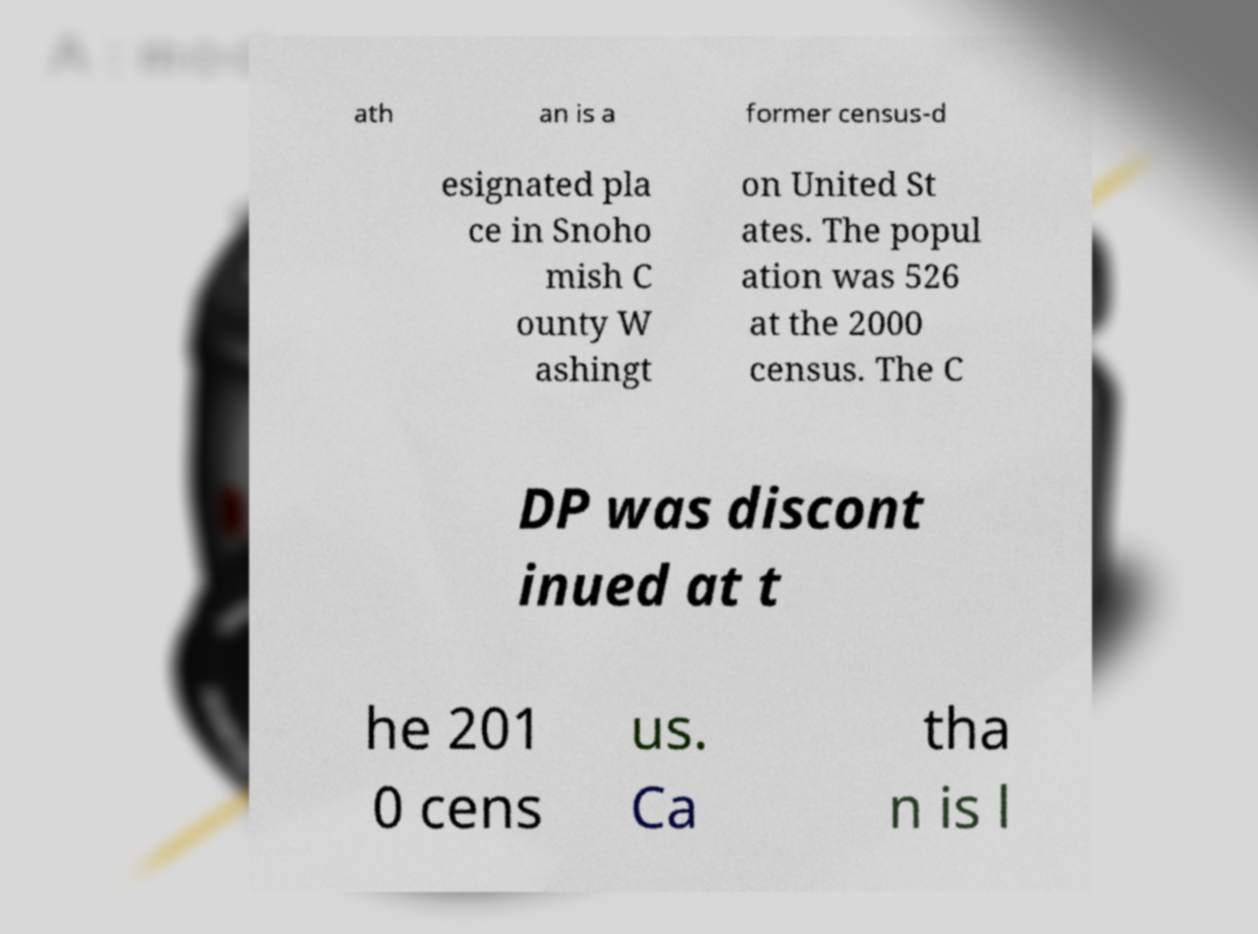Could you extract and type out the text from this image? ath an is a former census-d esignated pla ce in Snoho mish C ounty W ashingt on United St ates. The popul ation was 526 at the 2000 census. The C DP was discont inued at t he 201 0 cens us. Ca tha n is l 